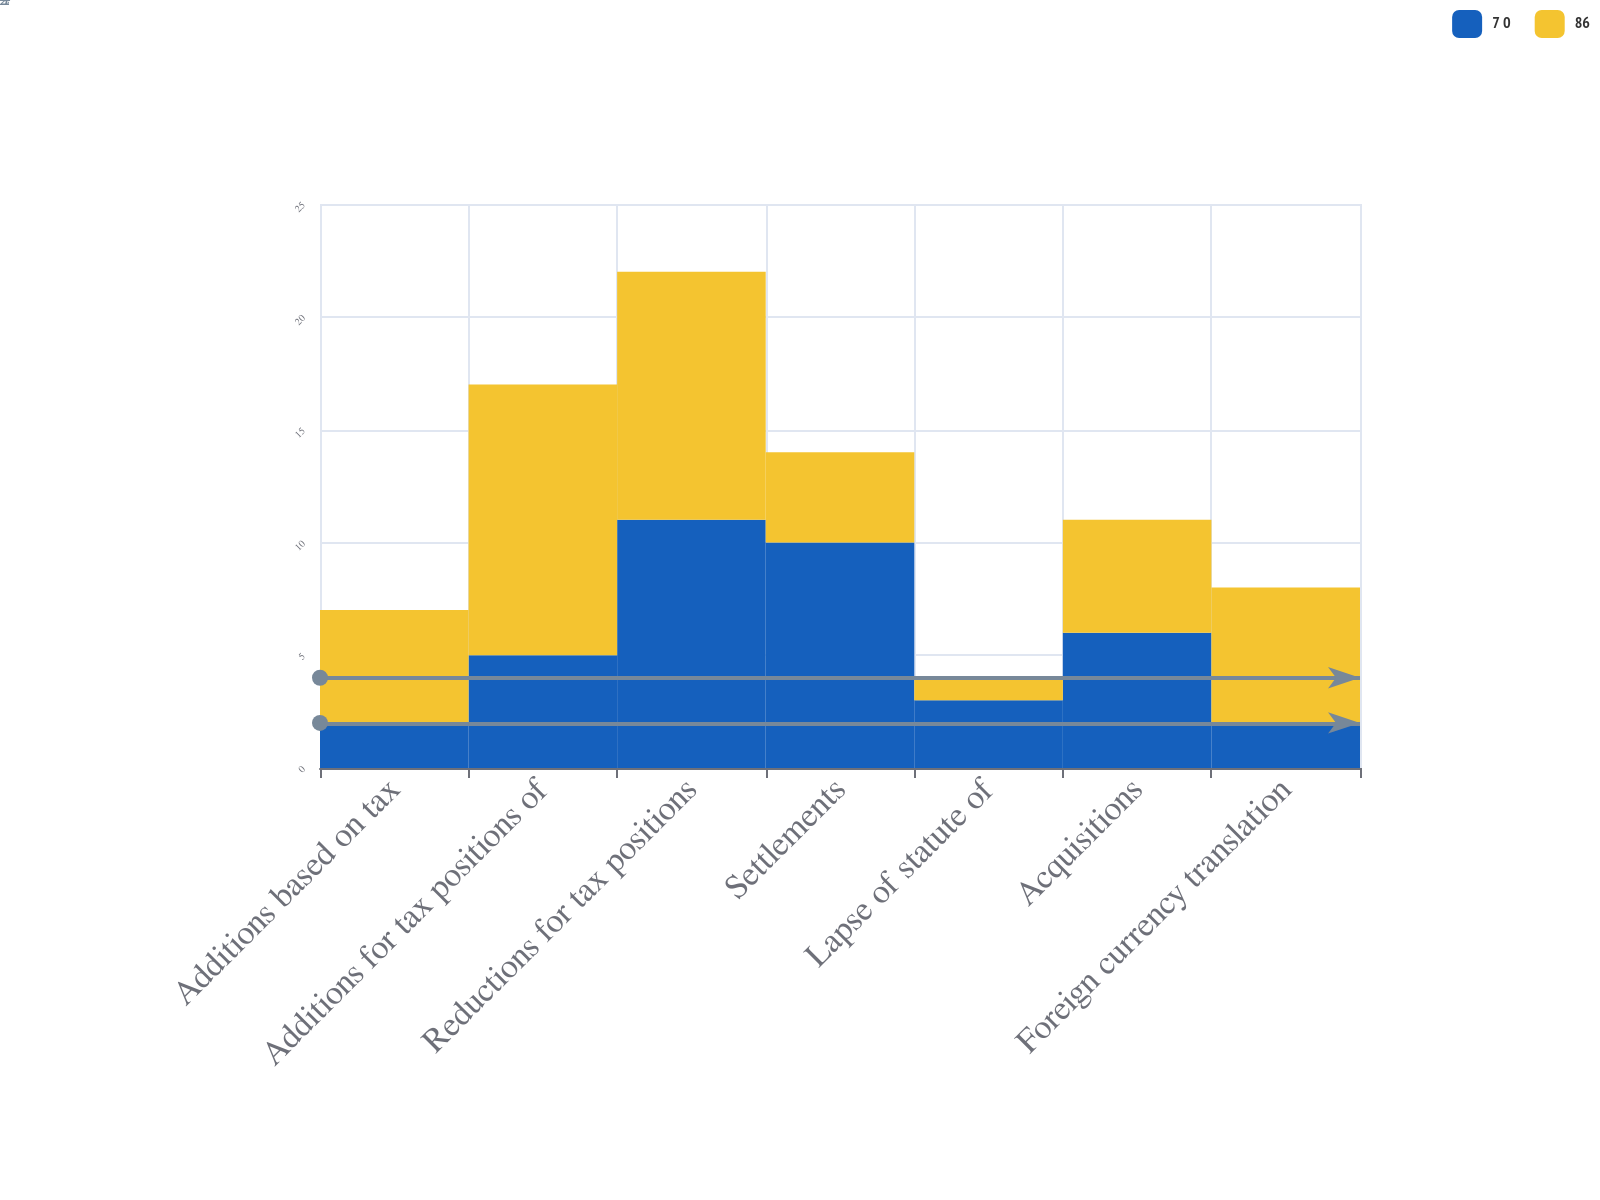Convert chart. <chart><loc_0><loc_0><loc_500><loc_500><stacked_bar_chart><ecel><fcel>Additions based on tax<fcel>Additions for tax positions of<fcel>Reductions for tax positions<fcel>Settlements<fcel>Lapse of statute of<fcel>Acquisitions<fcel>Foreign currency translation<nl><fcel>7 0<fcel>2<fcel>5<fcel>11<fcel>10<fcel>3<fcel>6<fcel>2<nl><fcel>86<fcel>5<fcel>12<fcel>11<fcel>4<fcel>1<fcel>5<fcel>6<nl></chart> 